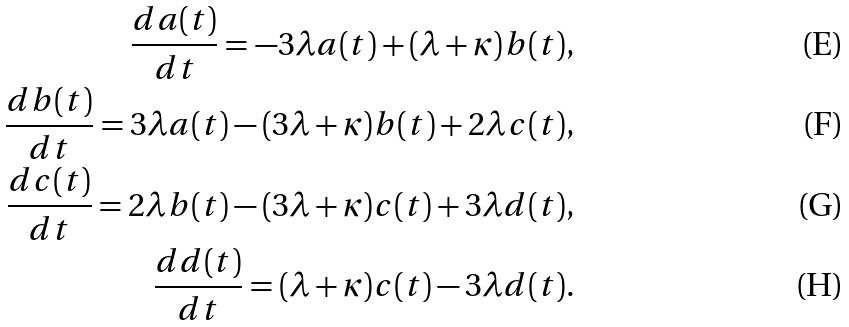Convert formula to latex. <formula><loc_0><loc_0><loc_500><loc_500>\frac { d a ( t ) } { d t } = - 3 \lambda a ( t ) + ( \lambda + \kappa ) b ( t ) , \\ \frac { d b ( t ) } { d t } = 3 \lambda a ( t ) - ( 3 \lambda + \kappa ) b ( t ) + 2 \lambda c ( t ) , \\ \frac { d c ( t ) } { d t } = 2 \lambda b ( t ) - ( 3 \lambda + \kappa ) c ( t ) + 3 \lambda d ( t ) , \\ \frac { d d ( t ) } { d t } = ( \lambda + \kappa ) c ( t ) - 3 \lambda d ( t ) .</formula> 